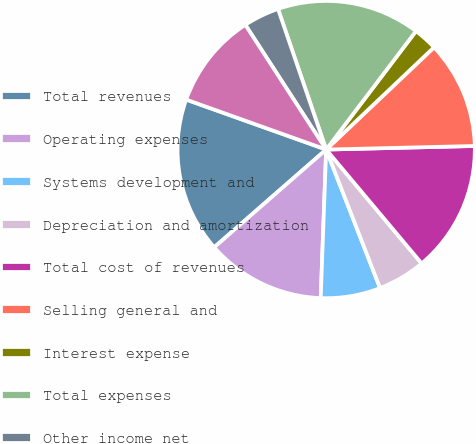Convert chart. <chart><loc_0><loc_0><loc_500><loc_500><pie_chart><fcel>Total revenues<fcel>Operating expenses<fcel>Systems development and<fcel>Depreciation and amortization<fcel>Total cost of revenues<fcel>Selling general and<fcel>Interest expense<fcel>Total expenses<fcel>Other income net<fcel>Earnings from continuing<nl><fcel>16.88%<fcel>12.99%<fcel>6.49%<fcel>5.2%<fcel>14.28%<fcel>11.69%<fcel>2.6%<fcel>15.58%<fcel>3.9%<fcel>10.39%<nl></chart> 